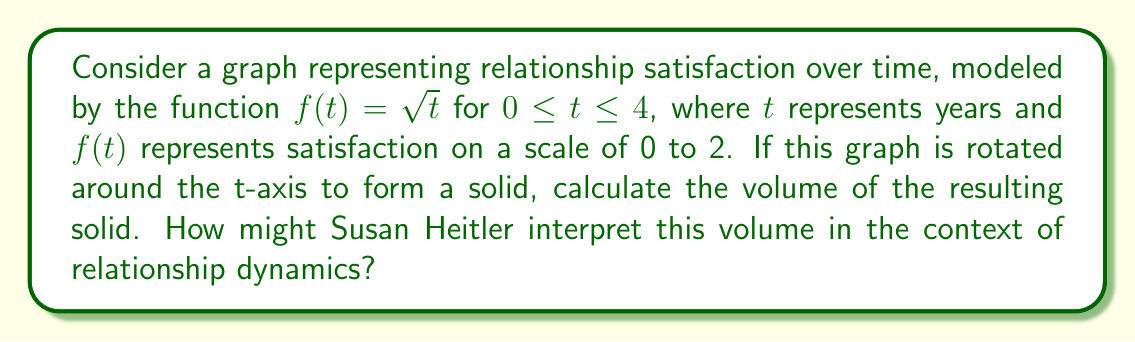Teach me how to tackle this problem. To solve this problem, we'll use the shell method for calculating the volume of a solid of revolution. The shell method is appropriate here because we're rotating around the t-axis (horizontal axis).

The formula for the shell method is:

$$V = 2\pi \int_a^b y(x) \cdot x \, dx$$

In our case, we'll use $t$ instead of $x$:

$$V = 2\pi \int_0^4 f(t) \cdot t \, dt$$

Step 1: Substitute the function $f(t) = \sqrt{t}$ into the formula:

$$V = 2\pi \int_0^4 \sqrt{t} \cdot t \, dt$$

Step 2: Simplify the integrand:

$$V = 2\pi \int_0^4 t^{3/2} \, dt$$

Step 3: Integrate using the power rule:

$$V = 2\pi \left[ \frac{2}{5}t^{5/2} \right]_0^4$$

Step 4: Evaluate the integral:

$$V = 2\pi \left( \frac{2}{5}(4^{5/2}) - \frac{2}{5}(0^{5/2}) \right)$$
$$V = 2\pi \cdot \frac{2}{5} \cdot 4^{5/2}$$
$$V = \frac{4\pi}{5} \cdot 32$$
$$V = \frac{128\pi}{5}$$

Step 5: Simplify:

$$V = 25.6\pi \approx 80.42$$

In the context of Susan Heitler's work on relationship dynamics, this volume could be interpreted as a measure of overall relationship satisfaction accumulated over time. The increasing rate of satisfaction (represented by the square root function) suggests that as couples work through issues and develop stronger bonds, their satisfaction grows more rapidly. The volume represents the total "amount" of satisfaction experienced, taking into account both the level of satisfaction and the time over which it was experienced.
Answer: The volume of the solid formed by rotating the graph around the t-axis is $\frac{128\pi}{5}$ cubic units, or approximately 80.42 cubic units. 